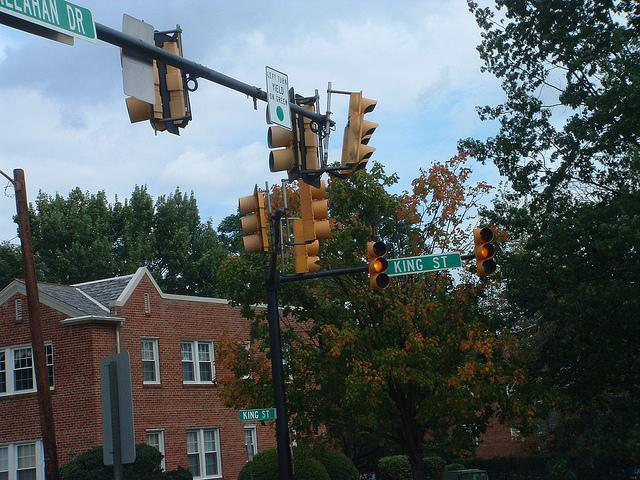Who would be married to the person that is listed on the street name?

Choices:
A) dauphine
B) princess
C) queen
D) duchess queen 